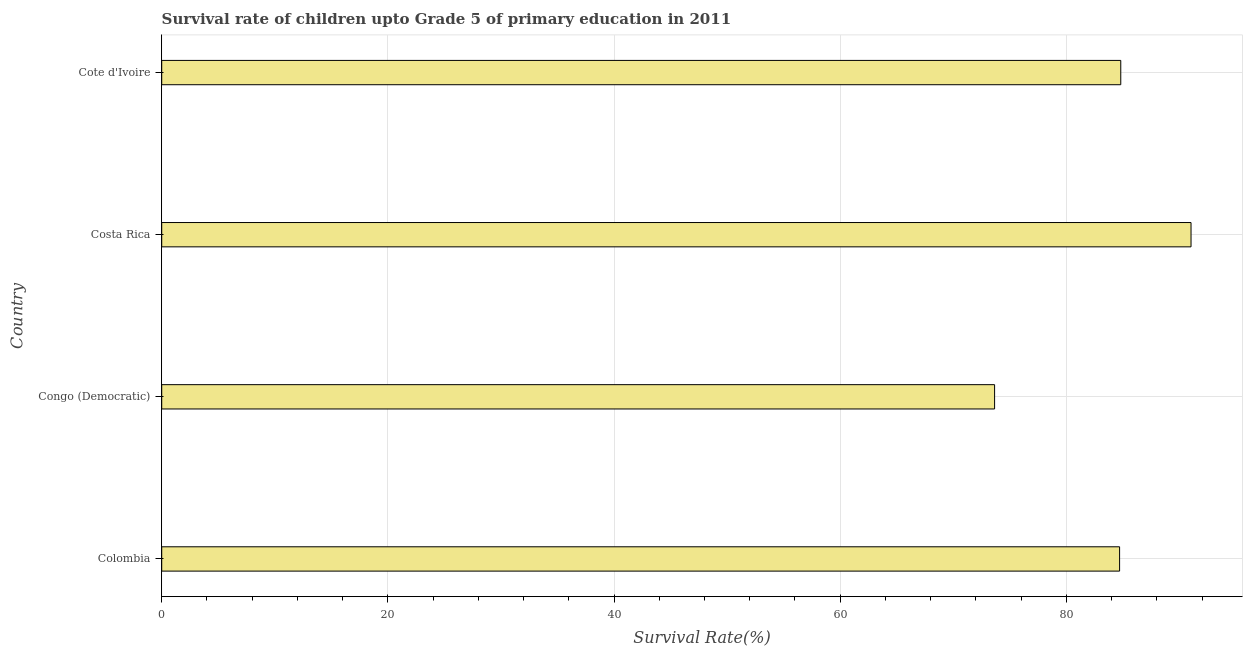What is the title of the graph?
Provide a succinct answer. Survival rate of children upto Grade 5 of primary education in 2011 . What is the label or title of the X-axis?
Ensure brevity in your answer.  Survival Rate(%). What is the survival rate in Cote d'Ivoire?
Your answer should be compact. 84.81. Across all countries, what is the maximum survival rate?
Keep it short and to the point. 91.03. Across all countries, what is the minimum survival rate?
Your answer should be compact. 73.66. In which country was the survival rate minimum?
Provide a short and direct response. Congo (Democratic). What is the sum of the survival rate?
Give a very brief answer. 334.21. What is the difference between the survival rate in Congo (Democratic) and Cote d'Ivoire?
Make the answer very short. -11.16. What is the average survival rate per country?
Your answer should be compact. 83.55. What is the median survival rate?
Give a very brief answer. 84.76. In how many countries, is the survival rate greater than 84 %?
Your answer should be compact. 3. What is the ratio of the survival rate in Congo (Democratic) to that in Costa Rica?
Make the answer very short. 0.81. Is the survival rate in Colombia less than that in Costa Rica?
Your answer should be compact. Yes. What is the difference between the highest and the second highest survival rate?
Give a very brief answer. 6.21. What is the difference between the highest and the lowest survival rate?
Your answer should be very brief. 17.37. In how many countries, is the survival rate greater than the average survival rate taken over all countries?
Your response must be concise. 3. How many bars are there?
Give a very brief answer. 4. How many countries are there in the graph?
Your answer should be compact. 4. What is the difference between two consecutive major ticks on the X-axis?
Provide a succinct answer. 20. Are the values on the major ticks of X-axis written in scientific E-notation?
Ensure brevity in your answer.  No. What is the Survival Rate(%) in Colombia?
Ensure brevity in your answer.  84.71. What is the Survival Rate(%) of Congo (Democratic)?
Your answer should be very brief. 73.66. What is the Survival Rate(%) of Costa Rica?
Provide a short and direct response. 91.03. What is the Survival Rate(%) in Cote d'Ivoire?
Give a very brief answer. 84.81. What is the difference between the Survival Rate(%) in Colombia and Congo (Democratic)?
Ensure brevity in your answer.  11.06. What is the difference between the Survival Rate(%) in Colombia and Costa Rica?
Your response must be concise. -6.32. What is the difference between the Survival Rate(%) in Colombia and Cote d'Ivoire?
Offer a very short reply. -0.1. What is the difference between the Survival Rate(%) in Congo (Democratic) and Costa Rica?
Give a very brief answer. -17.37. What is the difference between the Survival Rate(%) in Congo (Democratic) and Cote d'Ivoire?
Provide a short and direct response. -11.16. What is the difference between the Survival Rate(%) in Costa Rica and Cote d'Ivoire?
Your answer should be very brief. 6.21. What is the ratio of the Survival Rate(%) in Colombia to that in Congo (Democratic)?
Your answer should be very brief. 1.15. What is the ratio of the Survival Rate(%) in Congo (Democratic) to that in Costa Rica?
Provide a short and direct response. 0.81. What is the ratio of the Survival Rate(%) in Congo (Democratic) to that in Cote d'Ivoire?
Keep it short and to the point. 0.87. What is the ratio of the Survival Rate(%) in Costa Rica to that in Cote d'Ivoire?
Keep it short and to the point. 1.07. 